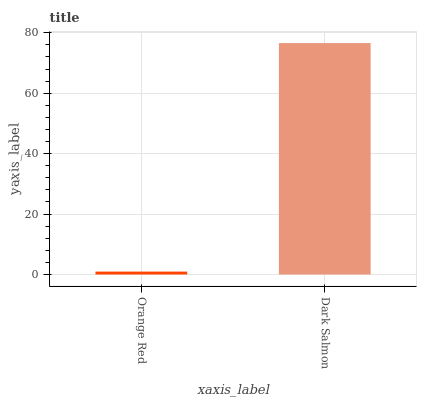Is Orange Red the minimum?
Answer yes or no. Yes. Is Dark Salmon the maximum?
Answer yes or no. Yes. Is Dark Salmon the minimum?
Answer yes or no. No. Is Dark Salmon greater than Orange Red?
Answer yes or no. Yes. Is Orange Red less than Dark Salmon?
Answer yes or no. Yes. Is Orange Red greater than Dark Salmon?
Answer yes or no. No. Is Dark Salmon less than Orange Red?
Answer yes or no. No. Is Dark Salmon the high median?
Answer yes or no. Yes. Is Orange Red the low median?
Answer yes or no. Yes. Is Orange Red the high median?
Answer yes or no. No. Is Dark Salmon the low median?
Answer yes or no. No. 